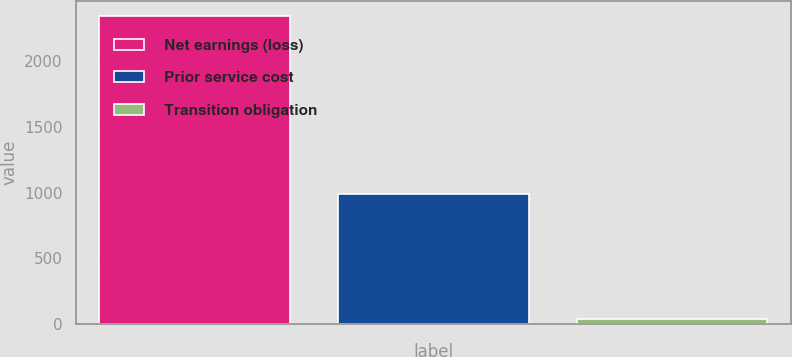<chart> <loc_0><loc_0><loc_500><loc_500><bar_chart><fcel>Net earnings (loss)<fcel>Prior service cost<fcel>Transition obligation<nl><fcel>2340<fcel>989<fcel>40<nl></chart> 